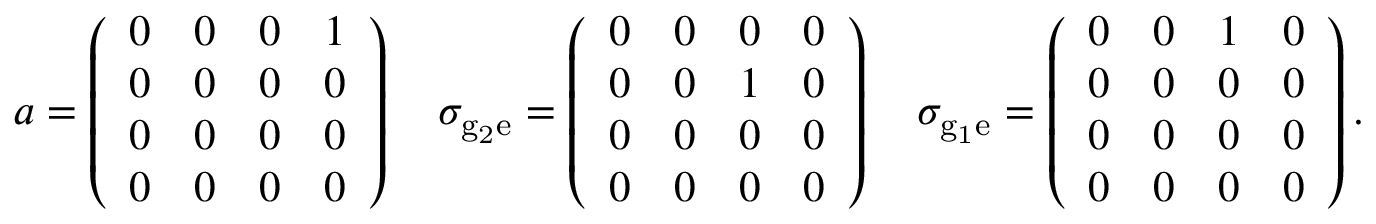Convert formula to latex. <formula><loc_0><loc_0><loc_500><loc_500>a = \left ( \begin{array} { l l l l } { 0 } & { 0 } & { 0 } & { 1 } \\ { 0 } & { 0 } & { 0 } & { 0 } \\ { 0 } & { 0 } & { 0 } & { 0 } \\ { 0 } & { 0 } & { 0 } & { 0 } \end{array} \right ) \quad \sigma _ { { g } _ { 2 } \mathrm { e } } = \left ( \begin{array} { l l l l } { 0 } & { 0 } & { 0 } & { 0 } \\ { 0 } & { 0 } & { 1 } & { 0 } \\ { 0 } & { 0 } & { 0 } & { 0 } \\ { 0 } & { 0 } & { 0 } & { 0 } \end{array} \right ) \quad \sigma _ { { g } _ { 1 } \mathrm { e } } = \left ( \begin{array} { l l l l } { 0 } & { 0 } & { 1 } & { 0 } \\ { 0 } & { 0 } & { 0 } & { 0 } \\ { 0 } & { 0 } & { 0 } & { 0 } \\ { 0 } & { 0 } & { 0 } & { 0 } \end{array} \right ) .</formula> 